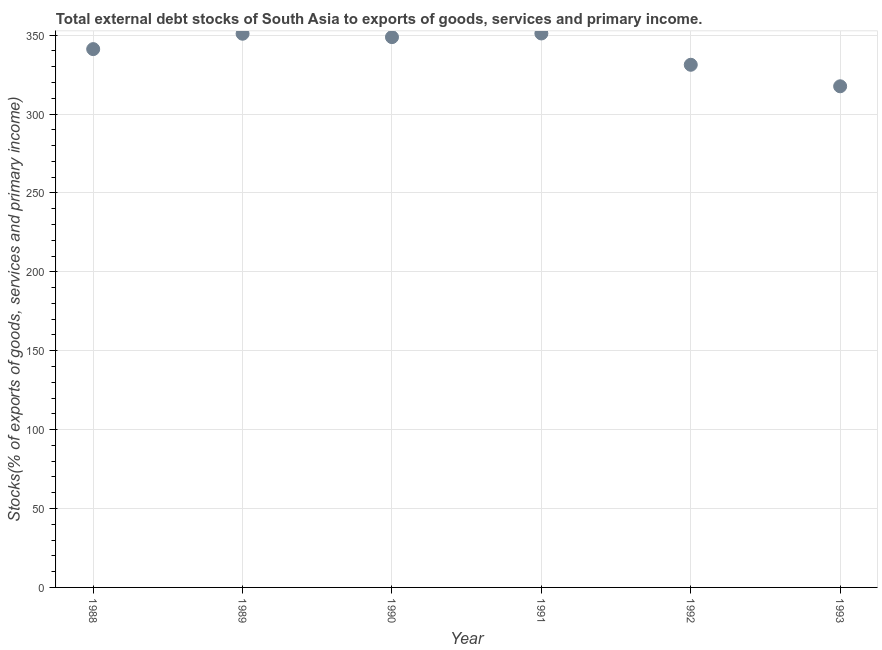What is the external debt stocks in 1988?
Provide a succinct answer. 341.14. Across all years, what is the maximum external debt stocks?
Your answer should be very brief. 351.05. Across all years, what is the minimum external debt stocks?
Your answer should be very brief. 317.57. In which year was the external debt stocks minimum?
Provide a short and direct response. 1993. What is the sum of the external debt stocks?
Your answer should be very brief. 2040.58. What is the difference between the external debt stocks in 1989 and 1990?
Keep it short and to the point. 2.16. What is the average external debt stocks per year?
Ensure brevity in your answer.  340.1. What is the median external debt stocks?
Give a very brief answer. 344.93. In how many years, is the external debt stocks greater than 90 %?
Give a very brief answer. 6. What is the ratio of the external debt stocks in 1988 to that in 1989?
Your answer should be very brief. 0.97. Is the difference between the external debt stocks in 1992 and 1993 greater than the difference between any two years?
Offer a terse response. No. What is the difference between the highest and the second highest external debt stocks?
Offer a very short reply. 0.16. What is the difference between the highest and the lowest external debt stocks?
Your answer should be compact. 33.48. In how many years, is the external debt stocks greater than the average external debt stocks taken over all years?
Offer a very short reply. 4. Does the external debt stocks monotonically increase over the years?
Provide a succinct answer. No. How many dotlines are there?
Make the answer very short. 1. What is the difference between two consecutive major ticks on the Y-axis?
Your answer should be very brief. 50. Are the values on the major ticks of Y-axis written in scientific E-notation?
Your response must be concise. No. What is the title of the graph?
Make the answer very short. Total external debt stocks of South Asia to exports of goods, services and primary income. What is the label or title of the X-axis?
Your response must be concise. Year. What is the label or title of the Y-axis?
Your response must be concise. Stocks(% of exports of goods, services and primary income). What is the Stocks(% of exports of goods, services and primary income) in 1988?
Ensure brevity in your answer.  341.14. What is the Stocks(% of exports of goods, services and primary income) in 1989?
Your answer should be compact. 350.89. What is the Stocks(% of exports of goods, services and primary income) in 1990?
Provide a succinct answer. 348.72. What is the Stocks(% of exports of goods, services and primary income) in 1991?
Ensure brevity in your answer.  351.05. What is the Stocks(% of exports of goods, services and primary income) in 1992?
Ensure brevity in your answer.  331.21. What is the Stocks(% of exports of goods, services and primary income) in 1993?
Your response must be concise. 317.57. What is the difference between the Stocks(% of exports of goods, services and primary income) in 1988 and 1989?
Provide a short and direct response. -9.75. What is the difference between the Stocks(% of exports of goods, services and primary income) in 1988 and 1990?
Offer a terse response. -7.59. What is the difference between the Stocks(% of exports of goods, services and primary income) in 1988 and 1991?
Ensure brevity in your answer.  -9.91. What is the difference between the Stocks(% of exports of goods, services and primary income) in 1988 and 1992?
Offer a terse response. 9.92. What is the difference between the Stocks(% of exports of goods, services and primary income) in 1988 and 1993?
Ensure brevity in your answer.  23.56. What is the difference between the Stocks(% of exports of goods, services and primary income) in 1989 and 1990?
Provide a succinct answer. 2.16. What is the difference between the Stocks(% of exports of goods, services and primary income) in 1989 and 1991?
Offer a terse response. -0.16. What is the difference between the Stocks(% of exports of goods, services and primary income) in 1989 and 1992?
Your response must be concise. 19.68. What is the difference between the Stocks(% of exports of goods, services and primary income) in 1989 and 1993?
Give a very brief answer. 33.32. What is the difference between the Stocks(% of exports of goods, services and primary income) in 1990 and 1991?
Ensure brevity in your answer.  -2.32. What is the difference between the Stocks(% of exports of goods, services and primary income) in 1990 and 1992?
Ensure brevity in your answer.  17.51. What is the difference between the Stocks(% of exports of goods, services and primary income) in 1990 and 1993?
Offer a very short reply. 31.15. What is the difference between the Stocks(% of exports of goods, services and primary income) in 1991 and 1992?
Your answer should be compact. 19.84. What is the difference between the Stocks(% of exports of goods, services and primary income) in 1991 and 1993?
Provide a short and direct response. 33.48. What is the difference between the Stocks(% of exports of goods, services and primary income) in 1992 and 1993?
Provide a succinct answer. 13.64. What is the ratio of the Stocks(% of exports of goods, services and primary income) in 1988 to that in 1989?
Ensure brevity in your answer.  0.97. What is the ratio of the Stocks(% of exports of goods, services and primary income) in 1988 to that in 1990?
Keep it short and to the point. 0.98. What is the ratio of the Stocks(% of exports of goods, services and primary income) in 1988 to that in 1993?
Your response must be concise. 1.07. What is the ratio of the Stocks(% of exports of goods, services and primary income) in 1989 to that in 1990?
Make the answer very short. 1.01. What is the ratio of the Stocks(% of exports of goods, services and primary income) in 1989 to that in 1991?
Provide a succinct answer. 1. What is the ratio of the Stocks(% of exports of goods, services and primary income) in 1989 to that in 1992?
Offer a terse response. 1.06. What is the ratio of the Stocks(% of exports of goods, services and primary income) in 1989 to that in 1993?
Provide a short and direct response. 1.1. What is the ratio of the Stocks(% of exports of goods, services and primary income) in 1990 to that in 1992?
Your answer should be compact. 1.05. What is the ratio of the Stocks(% of exports of goods, services and primary income) in 1990 to that in 1993?
Provide a succinct answer. 1.1. What is the ratio of the Stocks(% of exports of goods, services and primary income) in 1991 to that in 1992?
Make the answer very short. 1.06. What is the ratio of the Stocks(% of exports of goods, services and primary income) in 1991 to that in 1993?
Give a very brief answer. 1.1. What is the ratio of the Stocks(% of exports of goods, services and primary income) in 1992 to that in 1993?
Provide a short and direct response. 1.04. 